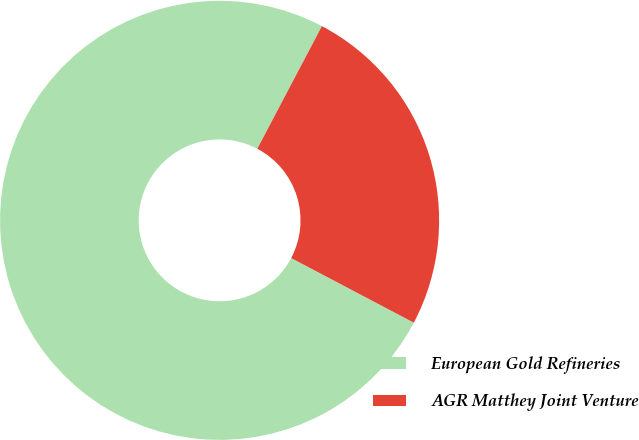Convert chart to OTSL. <chart><loc_0><loc_0><loc_500><loc_500><pie_chart><fcel>European Gold Refineries<fcel>AGR Matthey Joint Venture<nl><fcel>75.0%<fcel>25.0%<nl></chart> 